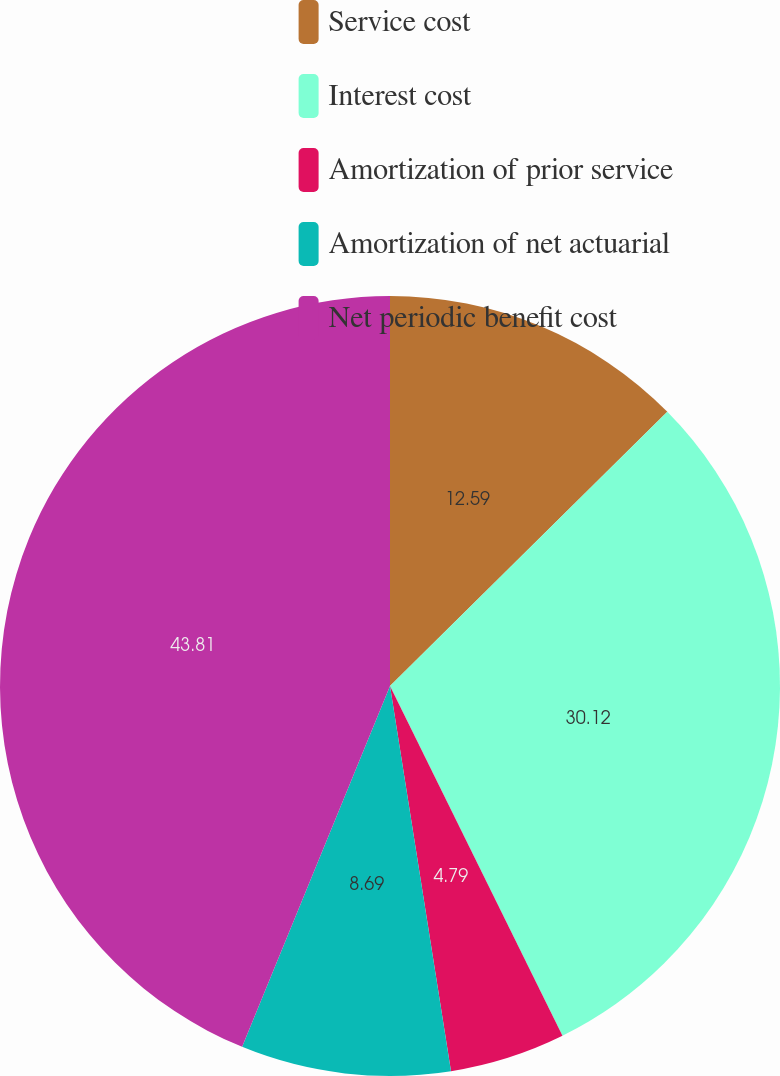Convert chart to OTSL. <chart><loc_0><loc_0><loc_500><loc_500><pie_chart><fcel>Service cost<fcel>Interest cost<fcel>Amortization of prior service<fcel>Amortization of net actuarial<fcel>Net periodic benefit cost<nl><fcel>12.59%<fcel>30.12%<fcel>4.79%<fcel>8.69%<fcel>43.81%<nl></chart> 